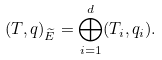Convert formula to latex. <formula><loc_0><loc_0><loc_500><loc_500>( T , q ) _ { \widetilde { E } } = \bigoplus _ { i = 1 } ^ { d } ( T _ { i } , q _ { i } ) .</formula> 